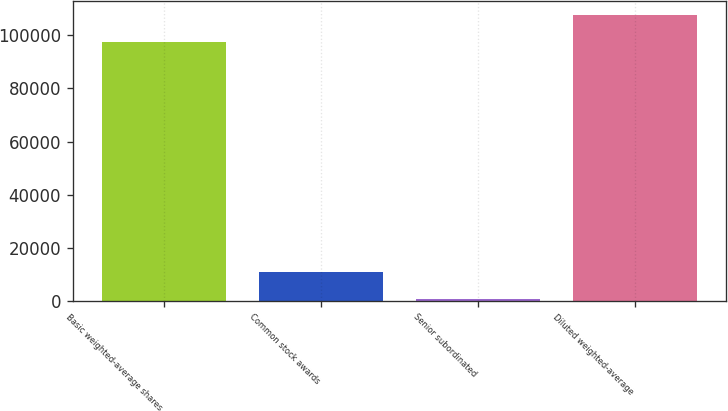Convert chart. <chart><loc_0><loc_0><loc_500><loc_500><bar_chart><fcel>Basic weighted-average shares<fcel>Common stock awards<fcel>Senior subordinated<fcel>Diluted weighted-average<nl><fcel>97702<fcel>10690.2<fcel>816<fcel>107576<nl></chart> 